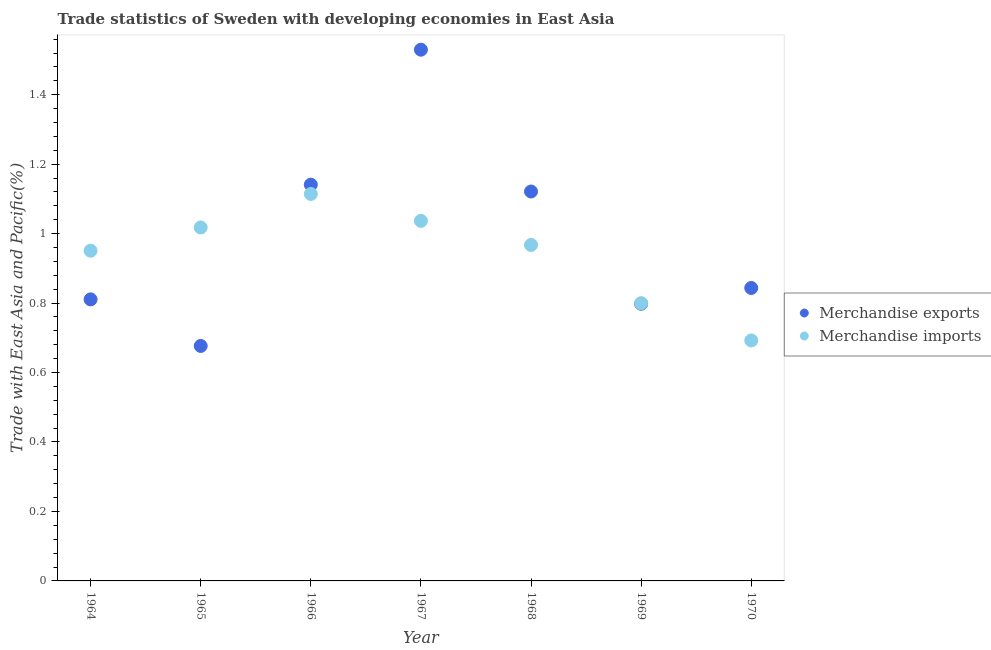How many different coloured dotlines are there?
Keep it short and to the point. 2. What is the merchandise exports in 1970?
Offer a terse response. 0.84. Across all years, what is the maximum merchandise imports?
Your answer should be compact. 1.11. Across all years, what is the minimum merchandise exports?
Offer a terse response. 0.68. In which year was the merchandise imports maximum?
Give a very brief answer. 1966. In which year was the merchandise exports minimum?
Provide a succinct answer. 1965. What is the total merchandise imports in the graph?
Give a very brief answer. 6.58. What is the difference between the merchandise exports in 1964 and that in 1969?
Give a very brief answer. 0.01. What is the difference between the merchandise imports in 1969 and the merchandise exports in 1964?
Your answer should be compact. -0.01. What is the average merchandise exports per year?
Keep it short and to the point. 0.99. In the year 1970, what is the difference between the merchandise imports and merchandise exports?
Provide a short and direct response. -0.15. What is the ratio of the merchandise exports in 1967 to that in 1970?
Keep it short and to the point. 1.81. Is the merchandise exports in 1967 less than that in 1969?
Give a very brief answer. No. Is the difference between the merchandise exports in 1964 and 1967 greater than the difference between the merchandise imports in 1964 and 1967?
Your answer should be very brief. No. What is the difference between the highest and the second highest merchandise imports?
Your answer should be compact. 0.08. What is the difference between the highest and the lowest merchandise imports?
Make the answer very short. 0.42. Is the sum of the merchandise exports in 1966 and 1968 greater than the maximum merchandise imports across all years?
Your answer should be compact. Yes. Does the merchandise exports monotonically increase over the years?
Give a very brief answer. No. How many dotlines are there?
Ensure brevity in your answer.  2. How many years are there in the graph?
Provide a short and direct response. 7. What is the difference between two consecutive major ticks on the Y-axis?
Your response must be concise. 0.2. Does the graph contain any zero values?
Your answer should be very brief. No. Does the graph contain grids?
Offer a very short reply. No. How are the legend labels stacked?
Offer a very short reply. Vertical. What is the title of the graph?
Make the answer very short. Trade statistics of Sweden with developing economies in East Asia. What is the label or title of the Y-axis?
Offer a terse response. Trade with East Asia and Pacific(%). What is the Trade with East Asia and Pacific(%) of Merchandise exports in 1964?
Keep it short and to the point. 0.81. What is the Trade with East Asia and Pacific(%) of Merchandise imports in 1964?
Your response must be concise. 0.95. What is the Trade with East Asia and Pacific(%) of Merchandise exports in 1965?
Ensure brevity in your answer.  0.68. What is the Trade with East Asia and Pacific(%) in Merchandise imports in 1965?
Offer a terse response. 1.02. What is the Trade with East Asia and Pacific(%) of Merchandise exports in 1966?
Offer a terse response. 1.14. What is the Trade with East Asia and Pacific(%) in Merchandise imports in 1966?
Your answer should be compact. 1.11. What is the Trade with East Asia and Pacific(%) in Merchandise exports in 1967?
Your answer should be very brief. 1.53. What is the Trade with East Asia and Pacific(%) of Merchandise imports in 1967?
Your answer should be compact. 1.04. What is the Trade with East Asia and Pacific(%) in Merchandise exports in 1968?
Keep it short and to the point. 1.12. What is the Trade with East Asia and Pacific(%) of Merchandise imports in 1968?
Provide a short and direct response. 0.97. What is the Trade with East Asia and Pacific(%) of Merchandise exports in 1969?
Your answer should be compact. 0.8. What is the Trade with East Asia and Pacific(%) of Merchandise imports in 1969?
Make the answer very short. 0.8. What is the Trade with East Asia and Pacific(%) of Merchandise exports in 1970?
Your answer should be compact. 0.84. What is the Trade with East Asia and Pacific(%) in Merchandise imports in 1970?
Provide a short and direct response. 0.69. Across all years, what is the maximum Trade with East Asia and Pacific(%) of Merchandise exports?
Ensure brevity in your answer.  1.53. Across all years, what is the maximum Trade with East Asia and Pacific(%) of Merchandise imports?
Keep it short and to the point. 1.11. Across all years, what is the minimum Trade with East Asia and Pacific(%) of Merchandise exports?
Your answer should be very brief. 0.68. Across all years, what is the minimum Trade with East Asia and Pacific(%) in Merchandise imports?
Your answer should be compact. 0.69. What is the total Trade with East Asia and Pacific(%) of Merchandise exports in the graph?
Provide a succinct answer. 6.92. What is the total Trade with East Asia and Pacific(%) in Merchandise imports in the graph?
Your response must be concise. 6.58. What is the difference between the Trade with East Asia and Pacific(%) in Merchandise exports in 1964 and that in 1965?
Ensure brevity in your answer.  0.13. What is the difference between the Trade with East Asia and Pacific(%) of Merchandise imports in 1964 and that in 1965?
Your response must be concise. -0.07. What is the difference between the Trade with East Asia and Pacific(%) in Merchandise exports in 1964 and that in 1966?
Your answer should be very brief. -0.33. What is the difference between the Trade with East Asia and Pacific(%) in Merchandise imports in 1964 and that in 1966?
Your answer should be very brief. -0.16. What is the difference between the Trade with East Asia and Pacific(%) in Merchandise exports in 1964 and that in 1967?
Offer a very short reply. -0.72. What is the difference between the Trade with East Asia and Pacific(%) in Merchandise imports in 1964 and that in 1967?
Your response must be concise. -0.09. What is the difference between the Trade with East Asia and Pacific(%) of Merchandise exports in 1964 and that in 1968?
Provide a short and direct response. -0.31. What is the difference between the Trade with East Asia and Pacific(%) in Merchandise imports in 1964 and that in 1968?
Your answer should be very brief. -0.02. What is the difference between the Trade with East Asia and Pacific(%) in Merchandise exports in 1964 and that in 1969?
Offer a very short reply. 0.01. What is the difference between the Trade with East Asia and Pacific(%) of Merchandise imports in 1964 and that in 1969?
Offer a very short reply. 0.15. What is the difference between the Trade with East Asia and Pacific(%) of Merchandise exports in 1964 and that in 1970?
Your answer should be compact. -0.03. What is the difference between the Trade with East Asia and Pacific(%) in Merchandise imports in 1964 and that in 1970?
Give a very brief answer. 0.26. What is the difference between the Trade with East Asia and Pacific(%) in Merchandise exports in 1965 and that in 1966?
Provide a succinct answer. -0.46. What is the difference between the Trade with East Asia and Pacific(%) in Merchandise imports in 1965 and that in 1966?
Provide a short and direct response. -0.1. What is the difference between the Trade with East Asia and Pacific(%) in Merchandise exports in 1965 and that in 1967?
Provide a succinct answer. -0.85. What is the difference between the Trade with East Asia and Pacific(%) in Merchandise imports in 1965 and that in 1967?
Offer a very short reply. -0.02. What is the difference between the Trade with East Asia and Pacific(%) of Merchandise exports in 1965 and that in 1968?
Your response must be concise. -0.44. What is the difference between the Trade with East Asia and Pacific(%) of Merchandise imports in 1965 and that in 1968?
Give a very brief answer. 0.05. What is the difference between the Trade with East Asia and Pacific(%) of Merchandise exports in 1965 and that in 1969?
Offer a terse response. -0.12. What is the difference between the Trade with East Asia and Pacific(%) of Merchandise imports in 1965 and that in 1969?
Offer a very short reply. 0.22. What is the difference between the Trade with East Asia and Pacific(%) of Merchandise exports in 1965 and that in 1970?
Offer a terse response. -0.17. What is the difference between the Trade with East Asia and Pacific(%) in Merchandise imports in 1965 and that in 1970?
Your response must be concise. 0.33. What is the difference between the Trade with East Asia and Pacific(%) of Merchandise exports in 1966 and that in 1967?
Give a very brief answer. -0.39. What is the difference between the Trade with East Asia and Pacific(%) of Merchandise imports in 1966 and that in 1967?
Provide a short and direct response. 0.08. What is the difference between the Trade with East Asia and Pacific(%) in Merchandise exports in 1966 and that in 1968?
Give a very brief answer. 0.02. What is the difference between the Trade with East Asia and Pacific(%) in Merchandise imports in 1966 and that in 1968?
Provide a succinct answer. 0.15. What is the difference between the Trade with East Asia and Pacific(%) in Merchandise exports in 1966 and that in 1969?
Offer a very short reply. 0.34. What is the difference between the Trade with East Asia and Pacific(%) in Merchandise imports in 1966 and that in 1969?
Ensure brevity in your answer.  0.31. What is the difference between the Trade with East Asia and Pacific(%) of Merchandise exports in 1966 and that in 1970?
Provide a succinct answer. 0.3. What is the difference between the Trade with East Asia and Pacific(%) in Merchandise imports in 1966 and that in 1970?
Give a very brief answer. 0.42. What is the difference between the Trade with East Asia and Pacific(%) in Merchandise exports in 1967 and that in 1968?
Your answer should be compact. 0.41. What is the difference between the Trade with East Asia and Pacific(%) in Merchandise imports in 1967 and that in 1968?
Offer a very short reply. 0.07. What is the difference between the Trade with East Asia and Pacific(%) of Merchandise exports in 1967 and that in 1969?
Offer a very short reply. 0.73. What is the difference between the Trade with East Asia and Pacific(%) of Merchandise imports in 1967 and that in 1969?
Your response must be concise. 0.24. What is the difference between the Trade with East Asia and Pacific(%) of Merchandise exports in 1967 and that in 1970?
Offer a very short reply. 0.69. What is the difference between the Trade with East Asia and Pacific(%) of Merchandise imports in 1967 and that in 1970?
Offer a terse response. 0.34. What is the difference between the Trade with East Asia and Pacific(%) of Merchandise exports in 1968 and that in 1969?
Your answer should be compact. 0.32. What is the difference between the Trade with East Asia and Pacific(%) of Merchandise imports in 1968 and that in 1969?
Give a very brief answer. 0.17. What is the difference between the Trade with East Asia and Pacific(%) of Merchandise exports in 1968 and that in 1970?
Give a very brief answer. 0.28. What is the difference between the Trade with East Asia and Pacific(%) in Merchandise imports in 1968 and that in 1970?
Make the answer very short. 0.28. What is the difference between the Trade with East Asia and Pacific(%) of Merchandise exports in 1969 and that in 1970?
Provide a short and direct response. -0.05. What is the difference between the Trade with East Asia and Pacific(%) in Merchandise imports in 1969 and that in 1970?
Give a very brief answer. 0.11. What is the difference between the Trade with East Asia and Pacific(%) in Merchandise exports in 1964 and the Trade with East Asia and Pacific(%) in Merchandise imports in 1965?
Make the answer very short. -0.21. What is the difference between the Trade with East Asia and Pacific(%) of Merchandise exports in 1964 and the Trade with East Asia and Pacific(%) of Merchandise imports in 1966?
Provide a succinct answer. -0.3. What is the difference between the Trade with East Asia and Pacific(%) in Merchandise exports in 1964 and the Trade with East Asia and Pacific(%) in Merchandise imports in 1967?
Your response must be concise. -0.23. What is the difference between the Trade with East Asia and Pacific(%) in Merchandise exports in 1964 and the Trade with East Asia and Pacific(%) in Merchandise imports in 1968?
Make the answer very short. -0.16. What is the difference between the Trade with East Asia and Pacific(%) in Merchandise exports in 1964 and the Trade with East Asia and Pacific(%) in Merchandise imports in 1969?
Your answer should be compact. 0.01. What is the difference between the Trade with East Asia and Pacific(%) in Merchandise exports in 1964 and the Trade with East Asia and Pacific(%) in Merchandise imports in 1970?
Your response must be concise. 0.12. What is the difference between the Trade with East Asia and Pacific(%) in Merchandise exports in 1965 and the Trade with East Asia and Pacific(%) in Merchandise imports in 1966?
Ensure brevity in your answer.  -0.44. What is the difference between the Trade with East Asia and Pacific(%) in Merchandise exports in 1965 and the Trade with East Asia and Pacific(%) in Merchandise imports in 1967?
Your answer should be very brief. -0.36. What is the difference between the Trade with East Asia and Pacific(%) in Merchandise exports in 1965 and the Trade with East Asia and Pacific(%) in Merchandise imports in 1968?
Your answer should be compact. -0.29. What is the difference between the Trade with East Asia and Pacific(%) of Merchandise exports in 1965 and the Trade with East Asia and Pacific(%) of Merchandise imports in 1969?
Ensure brevity in your answer.  -0.12. What is the difference between the Trade with East Asia and Pacific(%) of Merchandise exports in 1965 and the Trade with East Asia and Pacific(%) of Merchandise imports in 1970?
Provide a short and direct response. -0.02. What is the difference between the Trade with East Asia and Pacific(%) in Merchandise exports in 1966 and the Trade with East Asia and Pacific(%) in Merchandise imports in 1967?
Provide a short and direct response. 0.1. What is the difference between the Trade with East Asia and Pacific(%) of Merchandise exports in 1966 and the Trade with East Asia and Pacific(%) of Merchandise imports in 1968?
Give a very brief answer. 0.17. What is the difference between the Trade with East Asia and Pacific(%) in Merchandise exports in 1966 and the Trade with East Asia and Pacific(%) in Merchandise imports in 1969?
Make the answer very short. 0.34. What is the difference between the Trade with East Asia and Pacific(%) in Merchandise exports in 1966 and the Trade with East Asia and Pacific(%) in Merchandise imports in 1970?
Offer a very short reply. 0.45. What is the difference between the Trade with East Asia and Pacific(%) of Merchandise exports in 1967 and the Trade with East Asia and Pacific(%) of Merchandise imports in 1968?
Your answer should be very brief. 0.56. What is the difference between the Trade with East Asia and Pacific(%) of Merchandise exports in 1967 and the Trade with East Asia and Pacific(%) of Merchandise imports in 1969?
Offer a terse response. 0.73. What is the difference between the Trade with East Asia and Pacific(%) of Merchandise exports in 1967 and the Trade with East Asia and Pacific(%) of Merchandise imports in 1970?
Your answer should be compact. 0.84. What is the difference between the Trade with East Asia and Pacific(%) of Merchandise exports in 1968 and the Trade with East Asia and Pacific(%) of Merchandise imports in 1969?
Offer a terse response. 0.32. What is the difference between the Trade with East Asia and Pacific(%) in Merchandise exports in 1968 and the Trade with East Asia and Pacific(%) in Merchandise imports in 1970?
Provide a short and direct response. 0.43. What is the difference between the Trade with East Asia and Pacific(%) of Merchandise exports in 1969 and the Trade with East Asia and Pacific(%) of Merchandise imports in 1970?
Give a very brief answer. 0.11. What is the average Trade with East Asia and Pacific(%) in Merchandise imports per year?
Provide a succinct answer. 0.94. In the year 1964, what is the difference between the Trade with East Asia and Pacific(%) in Merchandise exports and Trade with East Asia and Pacific(%) in Merchandise imports?
Offer a very short reply. -0.14. In the year 1965, what is the difference between the Trade with East Asia and Pacific(%) of Merchandise exports and Trade with East Asia and Pacific(%) of Merchandise imports?
Make the answer very short. -0.34. In the year 1966, what is the difference between the Trade with East Asia and Pacific(%) of Merchandise exports and Trade with East Asia and Pacific(%) of Merchandise imports?
Your answer should be very brief. 0.03. In the year 1967, what is the difference between the Trade with East Asia and Pacific(%) of Merchandise exports and Trade with East Asia and Pacific(%) of Merchandise imports?
Give a very brief answer. 0.49. In the year 1968, what is the difference between the Trade with East Asia and Pacific(%) in Merchandise exports and Trade with East Asia and Pacific(%) in Merchandise imports?
Provide a succinct answer. 0.15. In the year 1969, what is the difference between the Trade with East Asia and Pacific(%) in Merchandise exports and Trade with East Asia and Pacific(%) in Merchandise imports?
Provide a succinct answer. -0. In the year 1970, what is the difference between the Trade with East Asia and Pacific(%) of Merchandise exports and Trade with East Asia and Pacific(%) of Merchandise imports?
Provide a succinct answer. 0.15. What is the ratio of the Trade with East Asia and Pacific(%) in Merchandise exports in 1964 to that in 1965?
Provide a short and direct response. 1.2. What is the ratio of the Trade with East Asia and Pacific(%) of Merchandise imports in 1964 to that in 1965?
Provide a short and direct response. 0.93. What is the ratio of the Trade with East Asia and Pacific(%) in Merchandise exports in 1964 to that in 1966?
Keep it short and to the point. 0.71. What is the ratio of the Trade with East Asia and Pacific(%) of Merchandise imports in 1964 to that in 1966?
Your response must be concise. 0.85. What is the ratio of the Trade with East Asia and Pacific(%) in Merchandise exports in 1964 to that in 1967?
Make the answer very short. 0.53. What is the ratio of the Trade with East Asia and Pacific(%) in Merchandise imports in 1964 to that in 1967?
Offer a very short reply. 0.92. What is the ratio of the Trade with East Asia and Pacific(%) of Merchandise exports in 1964 to that in 1968?
Provide a succinct answer. 0.72. What is the ratio of the Trade with East Asia and Pacific(%) in Merchandise imports in 1964 to that in 1968?
Offer a very short reply. 0.98. What is the ratio of the Trade with East Asia and Pacific(%) in Merchandise exports in 1964 to that in 1969?
Provide a short and direct response. 1.02. What is the ratio of the Trade with East Asia and Pacific(%) in Merchandise imports in 1964 to that in 1969?
Offer a very short reply. 1.19. What is the ratio of the Trade with East Asia and Pacific(%) in Merchandise exports in 1964 to that in 1970?
Your answer should be compact. 0.96. What is the ratio of the Trade with East Asia and Pacific(%) of Merchandise imports in 1964 to that in 1970?
Your response must be concise. 1.37. What is the ratio of the Trade with East Asia and Pacific(%) in Merchandise exports in 1965 to that in 1966?
Keep it short and to the point. 0.59. What is the ratio of the Trade with East Asia and Pacific(%) of Merchandise imports in 1965 to that in 1966?
Offer a terse response. 0.91. What is the ratio of the Trade with East Asia and Pacific(%) of Merchandise exports in 1965 to that in 1967?
Your answer should be very brief. 0.44. What is the ratio of the Trade with East Asia and Pacific(%) of Merchandise imports in 1965 to that in 1967?
Your answer should be compact. 0.98. What is the ratio of the Trade with East Asia and Pacific(%) of Merchandise exports in 1965 to that in 1968?
Ensure brevity in your answer.  0.6. What is the ratio of the Trade with East Asia and Pacific(%) in Merchandise imports in 1965 to that in 1968?
Provide a succinct answer. 1.05. What is the ratio of the Trade with East Asia and Pacific(%) of Merchandise exports in 1965 to that in 1969?
Provide a short and direct response. 0.85. What is the ratio of the Trade with East Asia and Pacific(%) of Merchandise imports in 1965 to that in 1969?
Provide a succinct answer. 1.27. What is the ratio of the Trade with East Asia and Pacific(%) in Merchandise exports in 1965 to that in 1970?
Provide a succinct answer. 0.8. What is the ratio of the Trade with East Asia and Pacific(%) of Merchandise imports in 1965 to that in 1970?
Your answer should be compact. 1.47. What is the ratio of the Trade with East Asia and Pacific(%) of Merchandise exports in 1966 to that in 1967?
Provide a succinct answer. 0.75. What is the ratio of the Trade with East Asia and Pacific(%) of Merchandise imports in 1966 to that in 1967?
Provide a short and direct response. 1.07. What is the ratio of the Trade with East Asia and Pacific(%) in Merchandise exports in 1966 to that in 1968?
Your response must be concise. 1.02. What is the ratio of the Trade with East Asia and Pacific(%) of Merchandise imports in 1966 to that in 1968?
Your answer should be very brief. 1.15. What is the ratio of the Trade with East Asia and Pacific(%) of Merchandise exports in 1966 to that in 1969?
Ensure brevity in your answer.  1.43. What is the ratio of the Trade with East Asia and Pacific(%) of Merchandise imports in 1966 to that in 1969?
Make the answer very short. 1.39. What is the ratio of the Trade with East Asia and Pacific(%) in Merchandise exports in 1966 to that in 1970?
Offer a terse response. 1.35. What is the ratio of the Trade with East Asia and Pacific(%) of Merchandise imports in 1966 to that in 1970?
Make the answer very short. 1.61. What is the ratio of the Trade with East Asia and Pacific(%) of Merchandise exports in 1967 to that in 1968?
Give a very brief answer. 1.36. What is the ratio of the Trade with East Asia and Pacific(%) in Merchandise imports in 1967 to that in 1968?
Your answer should be compact. 1.07. What is the ratio of the Trade with East Asia and Pacific(%) in Merchandise exports in 1967 to that in 1969?
Provide a short and direct response. 1.92. What is the ratio of the Trade with East Asia and Pacific(%) in Merchandise imports in 1967 to that in 1969?
Give a very brief answer. 1.3. What is the ratio of the Trade with East Asia and Pacific(%) of Merchandise exports in 1967 to that in 1970?
Give a very brief answer. 1.81. What is the ratio of the Trade with East Asia and Pacific(%) of Merchandise imports in 1967 to that in 1970?
Provide a short and direct response. 1.5. What is the ratio of the Trade with East Asia and Pacific(%) in Merchandise exports in 1968 to that in 1969?
Ensure brevity in your answer.  1.41. What is the ratio of the Trade with East Asia and Pacific(%) in Merchandise imports in 1968 to that in 1969?
Your response must be concise. 1.21. What is the ratio of the Trade with East Asia and Pacific(%) in Merchandise exports in 1968 to that in 1970?
Keep it short and to the point. 1.33. What is the ratio of the Trade with East Asia and Pacific(%) in Merchandise imports in 1968 to that in 1970?
Offer a very short reply. 1.4. What is the ratio of the Trade with East Asia and Pacific(%) of Merchandise exports in 1969 to that in 1970?
Ensure brevity in your answer.  0.95. What is the ratio of the Trade with East Asia and Pacific(%) in Merchandise imports in 1969 to that in 1970?
Give a very brief answer. 1.15. What is the difference between the highest and the second highest Trade with East Asia and Pacific(%) of Merchandise exports?
Your answer should be very brief. 0.39. What is the difference between the highest and the second highest Trade with East Asia and Pacific(%) in Merchandise imports?
Your response must be concise. 0.08. What is the difference between the highest and the lowest Trade with East Asia and Pacific(%) in Merchandise exports?
Keep it short and to the point. 0.85. What is the difference between the highest and the lowest Trade with East Asia and Pacific(%) in Merchandise imports?
Keep it short and to the point. 0.42. 